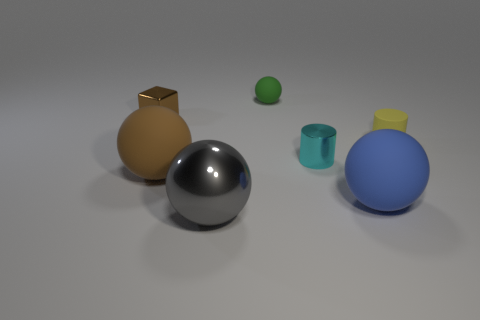Add 3 big green rubber balls. How many objects exist? 10 Subtract all cylinders. How many objects are left? 5 Subtract 0 green cylinders. How many objects are left? 7 Subtract all big red metallic cubes. Subtract all tiny green rubber objects. How many objects are left? 6 Add 5 small rubber spheres. How many small rubber spheres are left? 6 Add 6 cylinders. How many cylinders exist? 8 